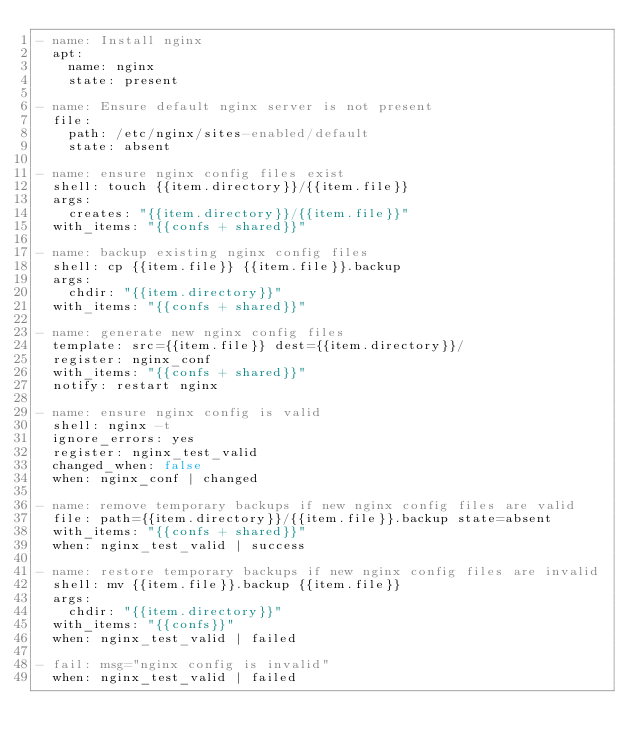Convert code to text. <code><loc_0><loc_0><loc_500><loc_500><_YAML_>- name: Install nginx
  apt:
    name: nginx
    state: present

- name: Ensure default nginx server is not present
  file:
    path: /etc/nginx/sites-enabled/default
    state: absent

- name: ensure nginx config files exist
  shell: touch {{item.directory}}/{{item.file}}
  args:
    creates: "{{item.directory}}/{{item.file}}"
  with_items: "{{confs + shared}}"

- name: backup existing nginx config files
  shell: cp {{item.file}} {{item.file}}.backup
  args:
    chdir: "{{item.directory}}"
  with_items: "{{confs + shared}}"

- name: generate new nginx config files
  template: src={{item.file}} dest={{item.directory}}/
  register: nginx_conf
  with_items: "{{confs + shared}}"
  notify: restart nginx

- name: ensure nginx config is valid
  shell: nginx -t
  ignore_errors: yes
  register: nginx_test_valid
  changed_when: false
  when: nginx_conf | changed

- name: remove temporary backups if new nginx config files are valid
  file: path={{item.directory}}/{{item.file}}.backup state=absent
  with_items: "{{confs + shared}}"
  when: nginx_test_valid | success

- name: restore temporary backups if new nginx config files are invalid
  shell: mv {{item.file}}.backup {{item.file}}
  args:
    chdir: "{{item.directory}}"
  with_items: "{{confs}}"
  when: nginx_test_valid | failed

- fail: msg="nginx config is invalid"
  when: nginx_test_valid | failed
</code> 